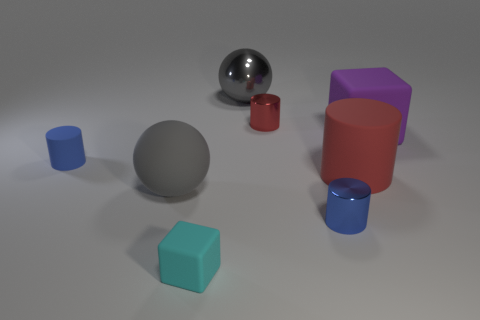How many cylinders have the same size as the cyan matte object?
Your response must be concise. 3. What is the shape of the metal object behind the red thing behind the large matte block?
Your answer should be very brief. Sphere. What shape is the tiny blue object to the right of the gray ball behind the ball on the left side of the large gray metallic thing?
Offer a very short reply. Cylinder. What number of other big matte things are the same shape as the cyan thing?
Ensure brevity in your answer.  1. How many small cyan rubber cubes are behind the purple object that is right of the big metal ball?
Offer a terse response. 0. What number of metallic objects are either big gray spheres or yellow things?
Offer a terse response. 1. Is there a big yellow cylinder made of the same material as the cyan block?
Your answer should be compact. No. What number of things are either cubes that are behind the tiny blue rubber thing or cylinders that are in front of the large purple rubber block?
Ensure brevity in your answer.  4. Is the color of the cube that is to the right of the large metallic object the same as the matte ball?
Your response must be concise. No. What number of other objects are there of the same color as the tiny block?
Offer a very short reply. 0. 